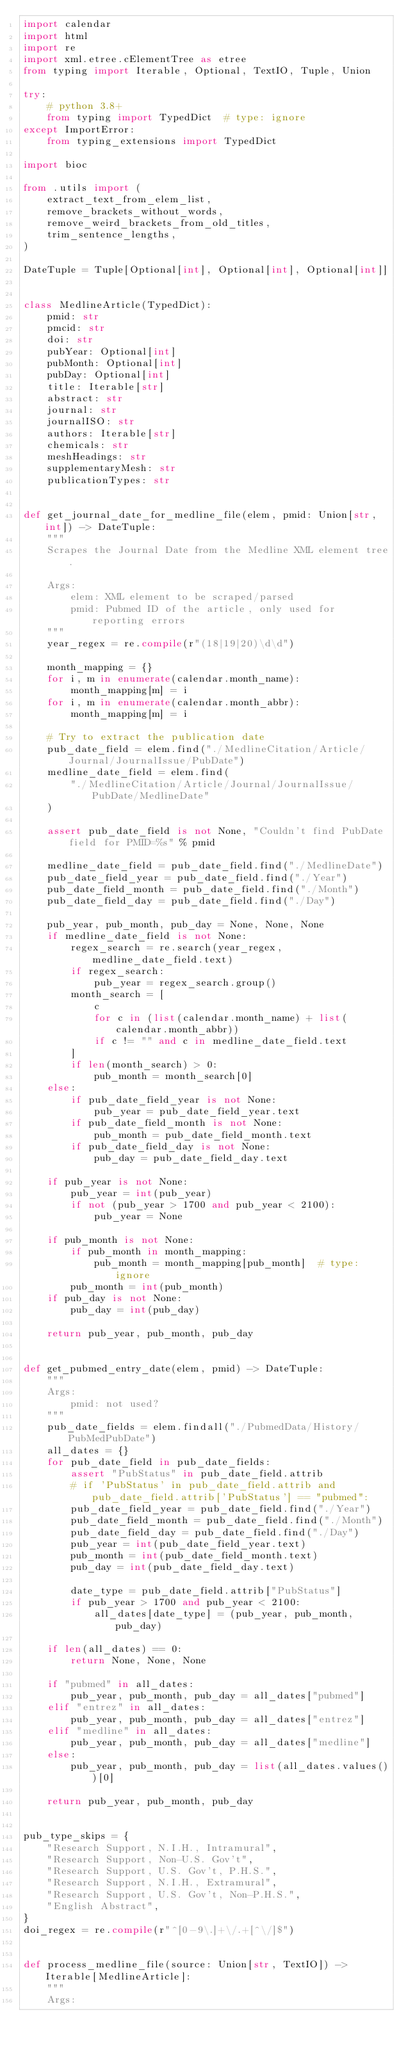<code> <loc_0><loc_0><loc_500><loc_500><_Python_>import calendar
import html
import re
import xml.etree.cElementTree as etree
from typing import Iterable, Optional, TextIO, Tuple, Union

try:
    # python 3.8+
    from typing import TypedDict  # type: ignore
except ImportError:
    from typing_extensions import TypedDict

import bioc

from .utils import (
    extract_text_from_elem_list,
    remove_brackets_without_words,
    remove_weird_brackets_from_old_titles,
    trim_sentence_lengths,
)

DateTuple = Tuple[Optional[int], Optional[int], Optional[int]]


class MedlineArticle(TypedDict):
    pmid: str
    pmcid: str
    doi: str
    pubYear: Optional[int]
    pubMonth: Optional[int]
    pubDay: Optional[int]
    title: Iterable[str]
    abstract: str
    journal: str
    journalISO: str
    authors: Iterable[str]
    chemicals: str
    meshHeadings: str
    supplementaryMesh: str
    publicationTypes: str


def get_journal_date_for_medline_file(elem, pmid: Union[str, int]) -> DateTuple:
    """
    Scrapes the Journal Date from the Medline XML element tree.

    Args:
        elem: XML element to be scraped/parsed
        pmid: Pubmed ID of the article, only used for reporting errors
    """
    year_regex = re.compile(r"(18|19|20)\d\d")

    month_mapping = {}
    for i, m in enumerate(calendar.month_name):
        month_mapping[m] = i
    for i, m in enumerate(calendar.month_abbr):
        month_mapping[m] = i

    # Try to extract the publication date
    pub_date_field = elem.find("./MedlineCitation/Article/Journal/JournalIssue/PubDate")
    medline_date_field = elem.find(
        "./MedlineCitation/Article/Journal/JournalIssue/PubDate/MedlineDate"
    )

    assert pub_date_field is not None, "Couldn't find PubDate field for PMID=%s" % pmid

    medline_date_field = pub_date_field.find("./MedlineDate")
    pub_date_field_year = pub_date_field.find("./Year")
    pub_date_field_month = pub_date_field.find("./Month")
    pub_date_field_day = pub_date_field.find("./Day")

    pub_year, pub_month, pub_day = None, None, None
    if medline_date_field is not None:
        regex_search = re.search(year_regex, medline_date_field.text)
        if regex_search:
            pub_year = regex_search.group()
        month_search = [
            c
            for c in (list(calendar.month_name) + list(calendar.month_abbr))
            if c != "" and c in medline_date_field.text
        ]
        if len(month_search) > 0:
            pub_month = month_search[0]
    else:
        if pub_date_field_year is not None:
            pub_year = pub_date_field_year.text
        if pub_date_field_month is not None:
            pub_month = pub_date_field_month.text
        if pub_date_field_day is not None:
            pub_day = pub_date_field_day.text

    if pub_year is not None:
        pub_year = int(pub_year)
        if not (pub_year > 1700 and pub_year < 2100):
            pub_year = None

    if pub_month is not None:
        if pub_month in month_mapping:
            pub_month = month_mapping[pub_month]  # type: ignore
        pub_month = int(pub_month)
    if pub_day is not None:
        pub_day = int(pub_day)

    return pub_year, pub_month, pub_day


def get_pubmed_entry_date(elem, pmid) -> DateTuple:
    """
    Args:
        pmid: not used?
    """
    pub_date_fields = elem.findall("./PubmedData/History/PubMedPubDate")
    all_dates = {}
    for pub_date_field in pub_date_fields:
        assert "PubStatus" in pub_date_field.attrib
        # if 'PubStatus' in pub_date_field.attrib and pub_date_field.attrib['PubStatus'] == "pubmed":
        pub_date_field_year = pub_date_field.find("./Year")
        pub_date_field_month = pub_date_field.find("./Month")
        pub_date_field_day = pub_date_field.find("./Day")
        pub_year = int(pub_date_field_year.text)
        pub_month = int(pub_date_field_month.text)
        pub_day = int(pub_date_field_day.text)

        date_type = pub_date_field.attrib["PubStatus"]
        if pub_year > 1700 and pub_year < 2100:
            all_dates[date_type] = (pub_year, pub_month, pub_day)

    if len(all_dates) == 0:
        return None, None, None

    if "pubmed" in all_dates:
        pub_year, pub_month, pub_day = all_dates["pubmed"]
    elif "entrez" in all_dates:
        pub_year, pub_month, pub_day = all_dates["entrez"]
    elif "medline" in all_dates:
        pub_year, pub_month, pub_day = all_dates["medline"]
    else:
        pub_year, pub_month, pub_day = list(all_dates.values())[0]

    return pub_year, pub_month, pub_day


pub_type_skips = {
    "Research Support, N.I.H., Intramural",
    "Research Support, Non-U.S. Gov't",
    "Research Support, U.S. Gov't, P.H.S.",
    "Research Support, N.I.H., Extramural",
    "Research Support, U.S. Gov't, Non-P.H.S.",
    "English Abstract",
}
doi_regex = re.compile(r"^[0-9\.]+\/.+[^\/]$")


def process_medline_file(source: Union[str, TextIO]) -> Iterable[MedlineArticle]:
    """
    Args:</code> 